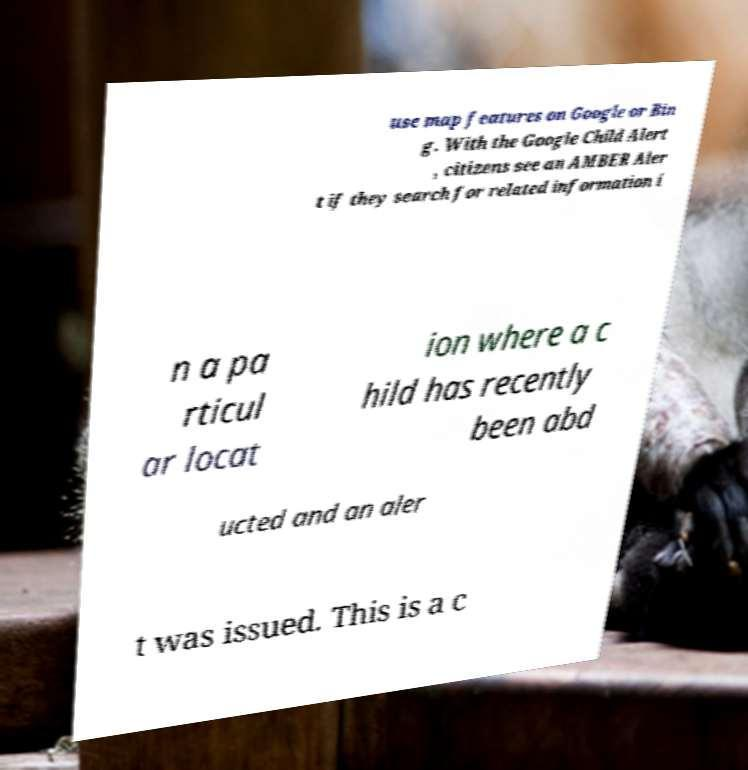I need the written content from this picture converted into text. Can you do that? use map features on Google or Bin g. With the Google Child Alert , citizens see an AMBER Aler t if they search for related information i n a pa rticul ar locat ion where a c hild has recently been abd ucted and an aler t was issued. This is a c 